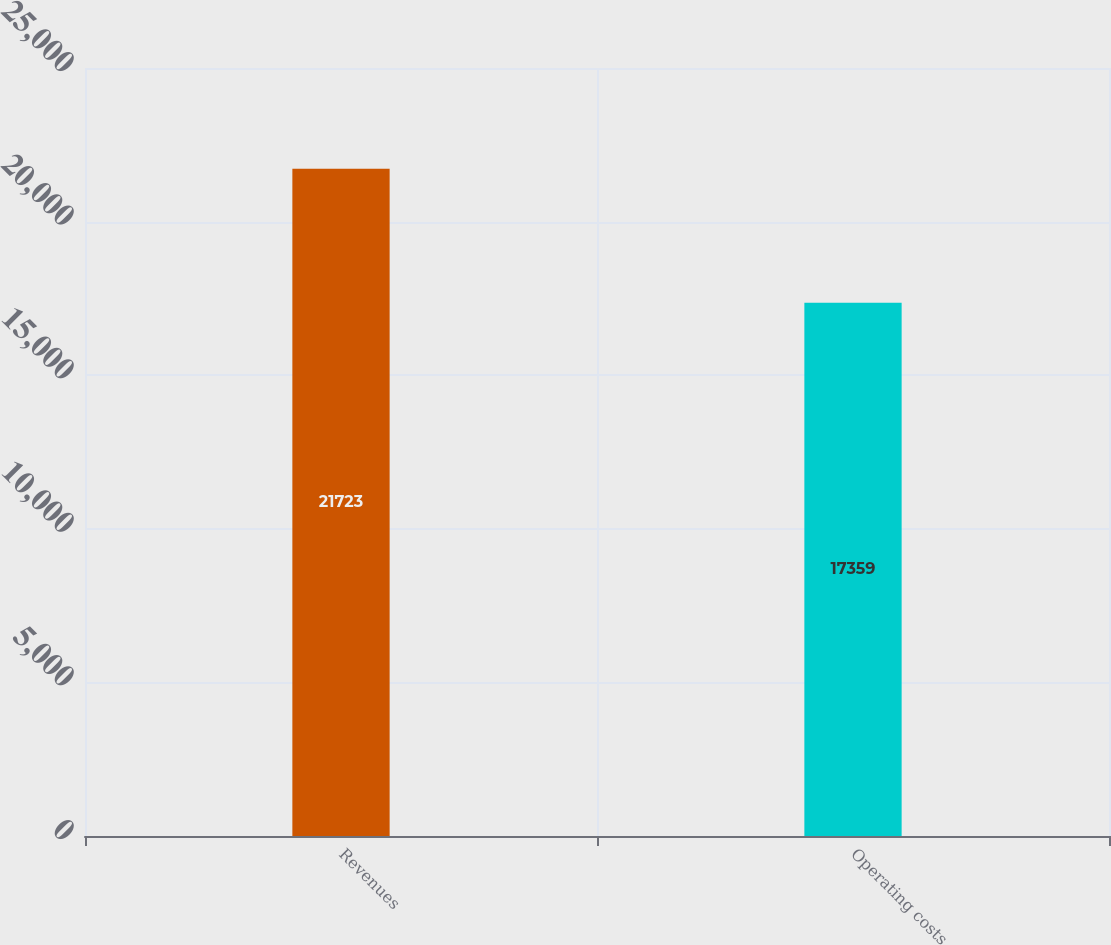Convert chart to OTSL. <chart><loc_0><loc_0><loc_500><loc_500><bar_chart><fcel>Revenues<fcel>Operating costs<nl><fcel>21723<fcel>17359<nl></chart> 